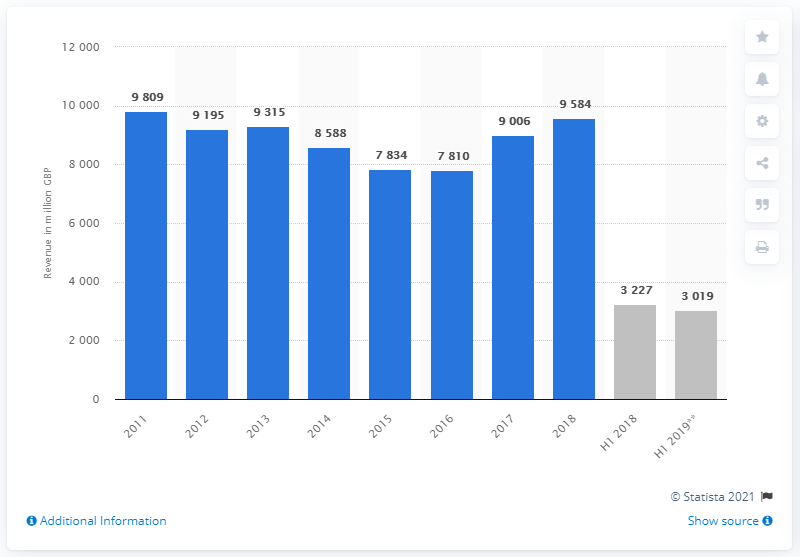Highlight a few significant elements in this photo. In 2018, Thomas Cook's revenue was 9,584. In 2017, Thomas Cook expanded its summer and winter programs. 